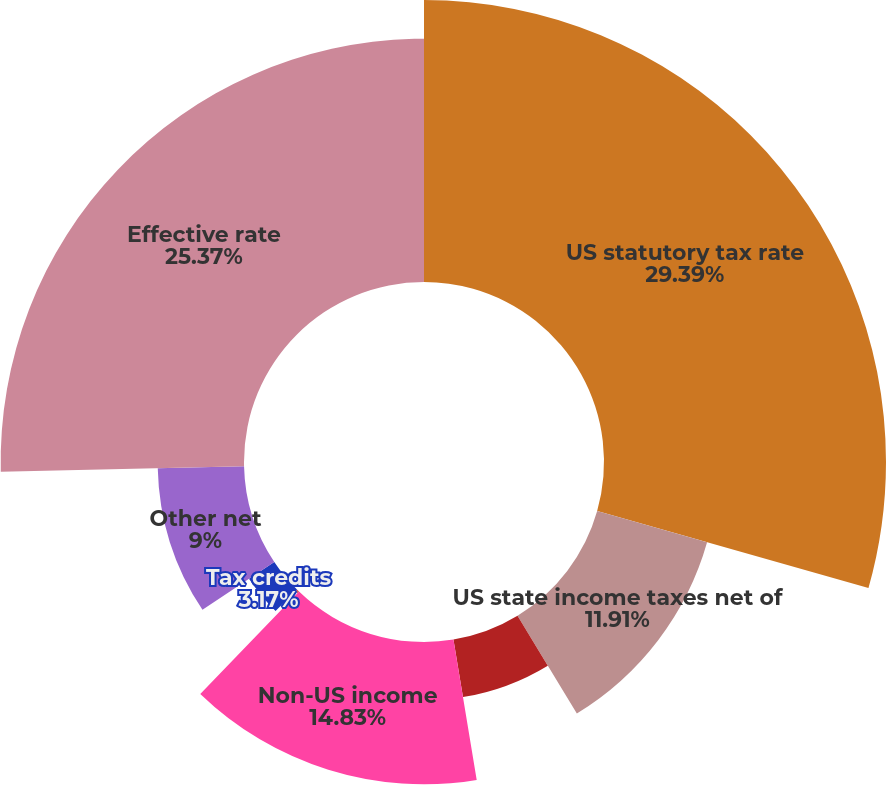<chart> <loc_0><loc_0><loc_500><loc_500><pie_chart><fcel>US statutory tax rate<fcel>US state income taxes net of<fcel>Nondeductible expenses<fcel>Non-US income<fcel>Change in valuation allowance<fcel>Tax credits<fcel>Other net<fcel>Effective rate<nl><fcel>29.4%<fcel>11.91%<fcel>6.08%<fcel>14.83%<fcel>0.25%<fcel>3.17%<fcel>9.0%<fcel>25.37%<nl></chart> 